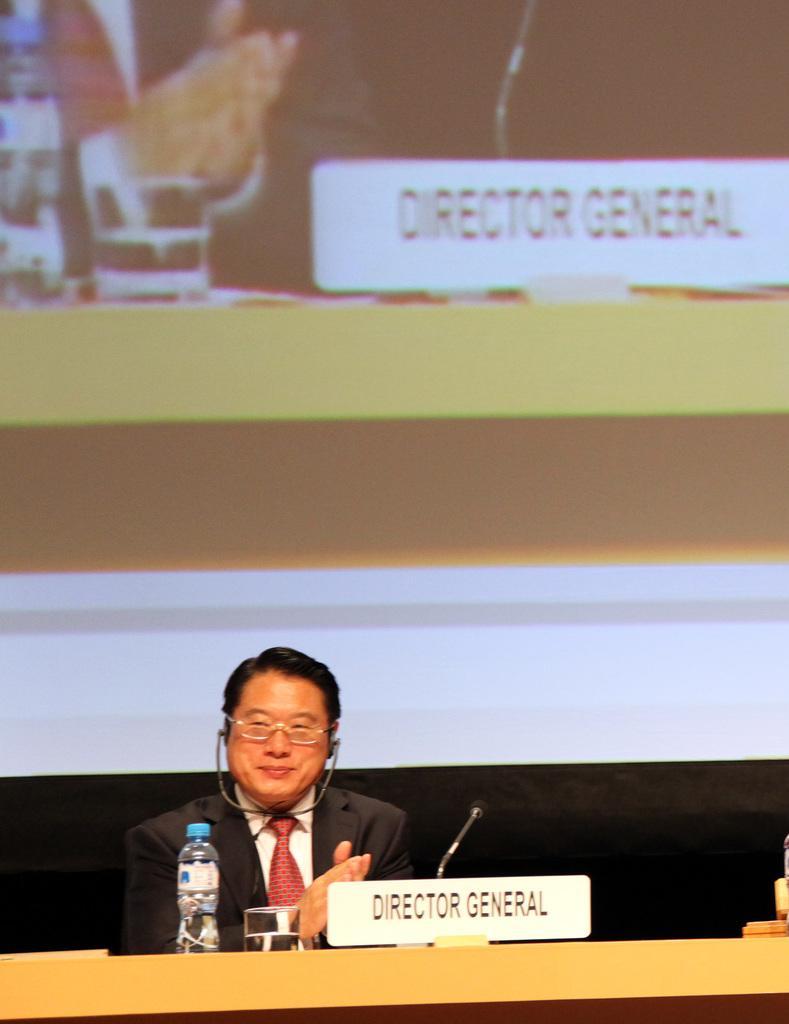In one or two sentences, can you explain what this image depicts? In this image we can see a man and he is clapping. He is wearing a suit and a tie and there is a smile on his face. Here we can see the table at the bottom. Here we can see the name plate board, a microphone, a glass of water and water bottle are kept on the table. In the background, we can see the screen. 